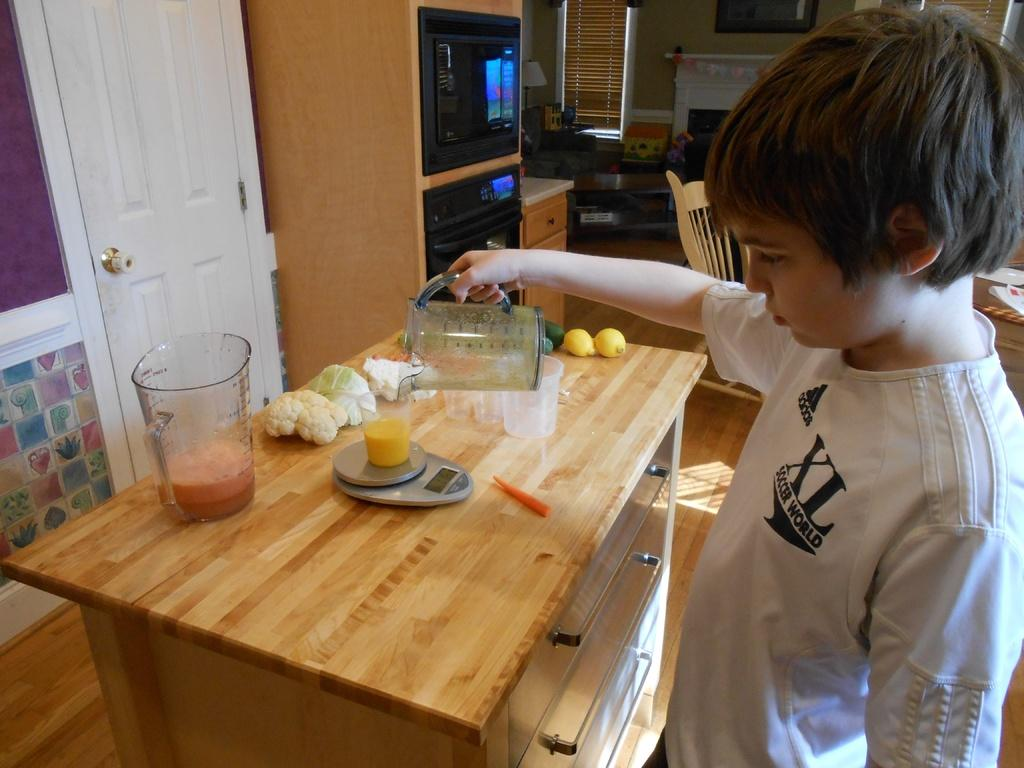<image>
Present a compact description of the photo's key features. A young boy with an XL Soccer world t shirt on pours orange juice into a cup. 